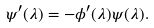<formula> <loc_0><loc_0><loc_500><loc_500>\psi ^ { \prime } ( \lambda ) = - \phi ^ { \prime } ( \lambda ) \psi ( \lambda ) .</formula> 